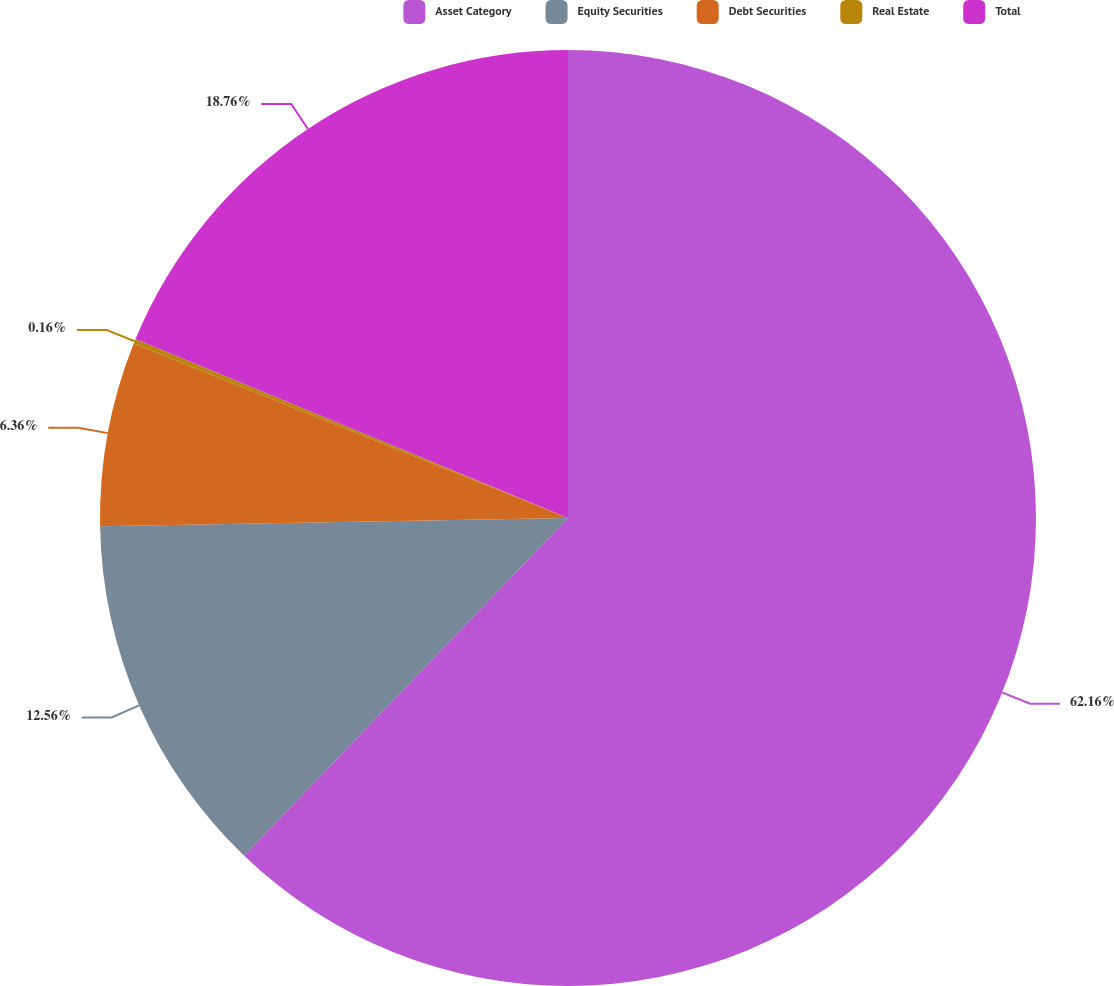<chart> <loc_0><loc_0><loc_500><loc_500><pie_chart><fcel>Asset Category<fcel>Equity Securities<fcel>Debt Securities<fcel>Real Estate<fcel>Total<nl><fcel>62.17%<fcel>12.56%<fcel>6.36%<fcel>0.16%<fcel>18.76%<nl></chart> 